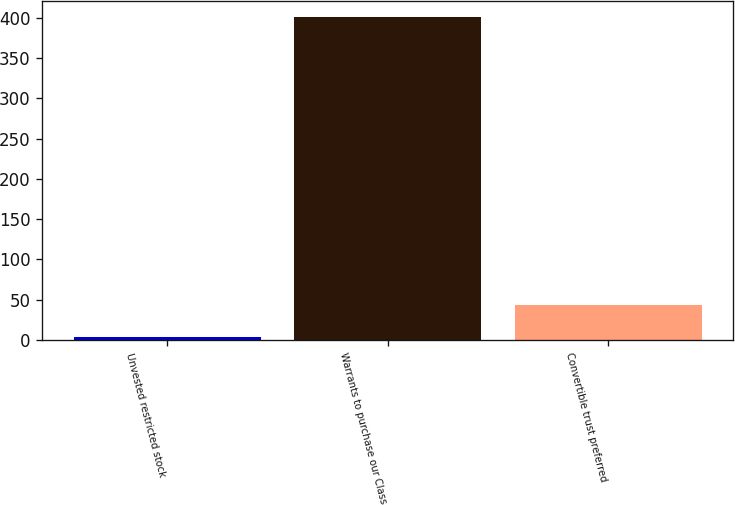<chart> <loc_0><loc_0><loc_500><loc_500><bar_chart><fcel>Unvested restricted stock<fcel>Warrants to purchase our Class<fcel>Convertible trust preferred<nl><fcel>4<fcel>401<fcel>43.7<nl></chart> 